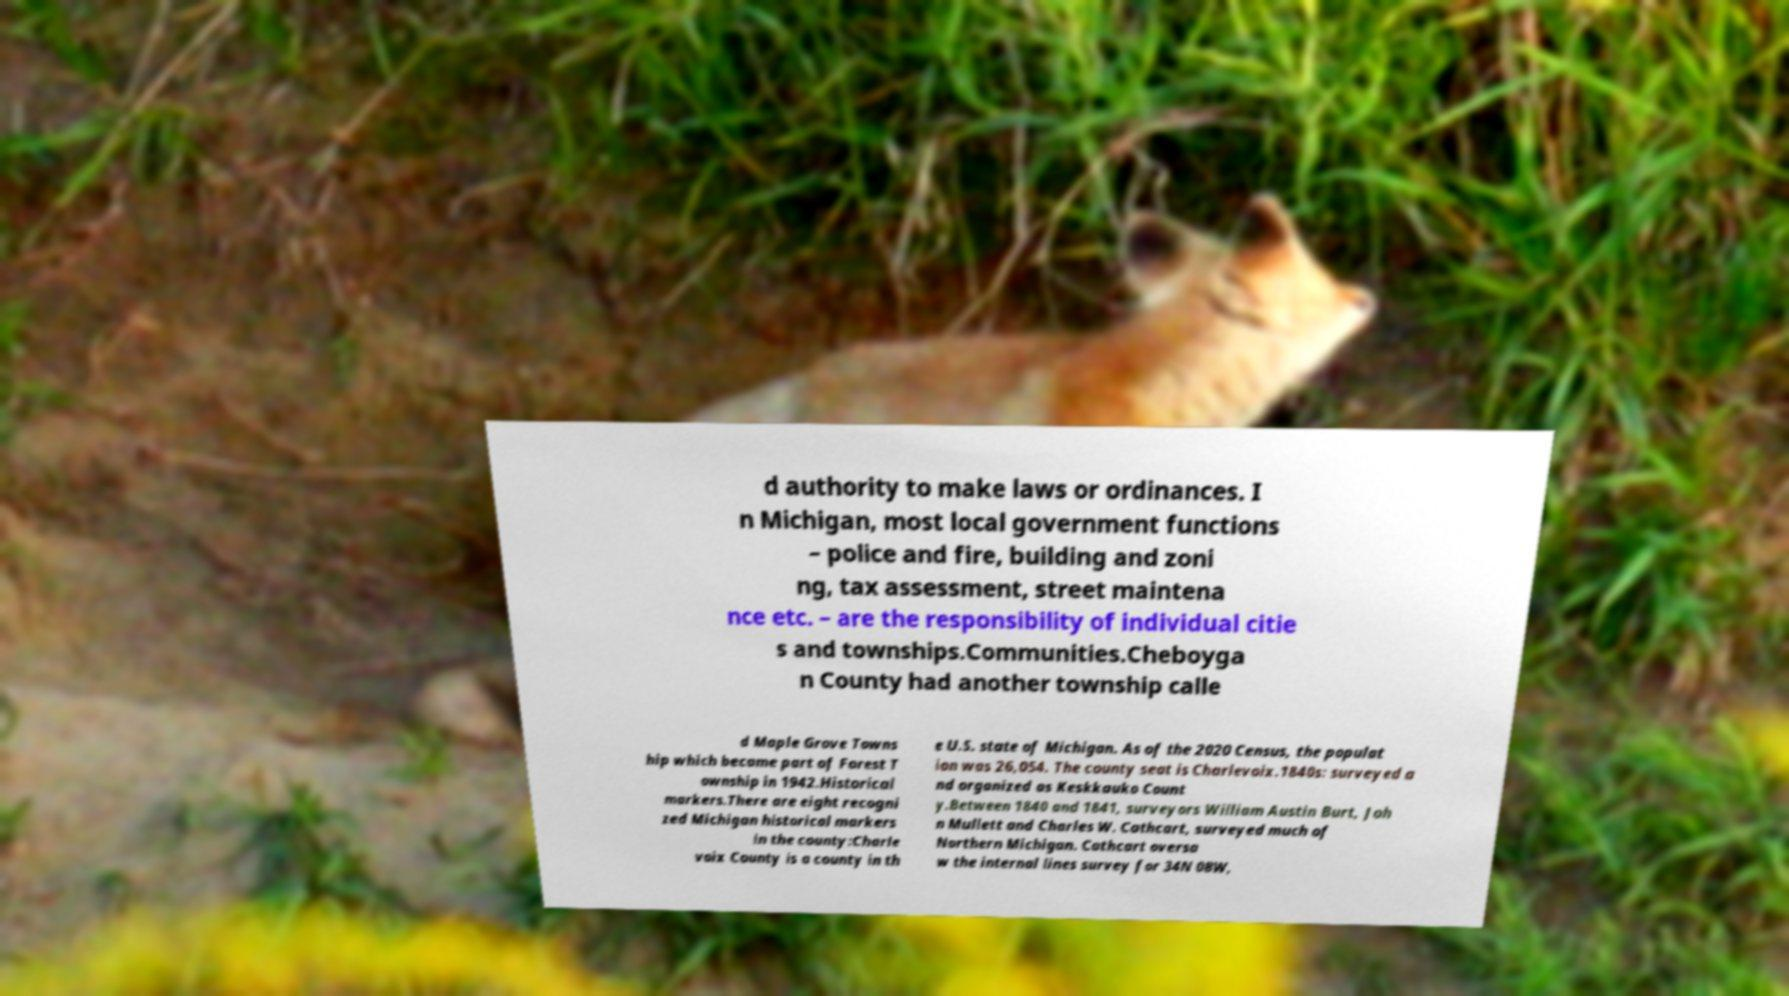Please read and relay the text visible in this image. What does it say? d authority to make laws or ordinances. I n Michigan, most local government functions – police and fire, building and zoni ng, tax assessment, street maintena nce etc. – are the responsibility of individual citie s and townships.Communities.Cheboyga n County had another township calle d Maple Grove Towns hip which became part of Forest T ownship in 1942.Historical markers.There are eight recogni zed Michigan historical markers in the county:Charle voix County is a county in th e U.S. state of Michigan. As of the 2020 Census, the populat ion was 26,054. The county seat is Charlevoix.1840s: surveyed a nd organized as Keskkauko Count y.Between 1840 and 1841, surveyors William Austin Burt, Joh n Mullett and Charles W. Cathcart, surveyed much of Northern Michigan. Cathcart oversa w the internal lines survey for 34N 08W, 